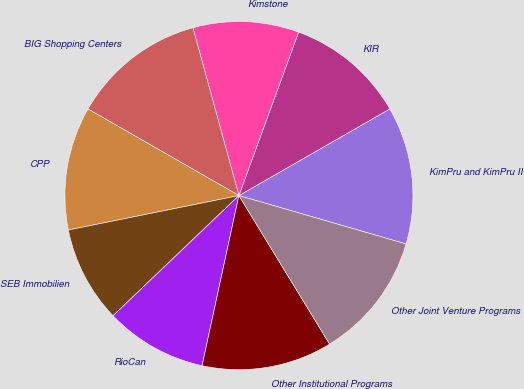Convert chart to OTSL. <chart><loc_0><loc_0><loc_500><loc_500><pie_chart><fcel>KimPru and KimPru II<fcel>KIR<fcel>Kimstone<fcel>BIG Shopping Centers<fcel>CPP<fcel>SEB Immobilien<fcel>RioCan<fcel>Other Institutional Programs<fcel>Other Joint Venture Programs<nl><fcel>12.78%<fcel>11.13%<fcel>9.83%<fcel>12.45%<fcel>11.46%<fcel>8.96%<fcel>9.47%<fcel>12.12%<fcel>11.79%<nl></chart> 